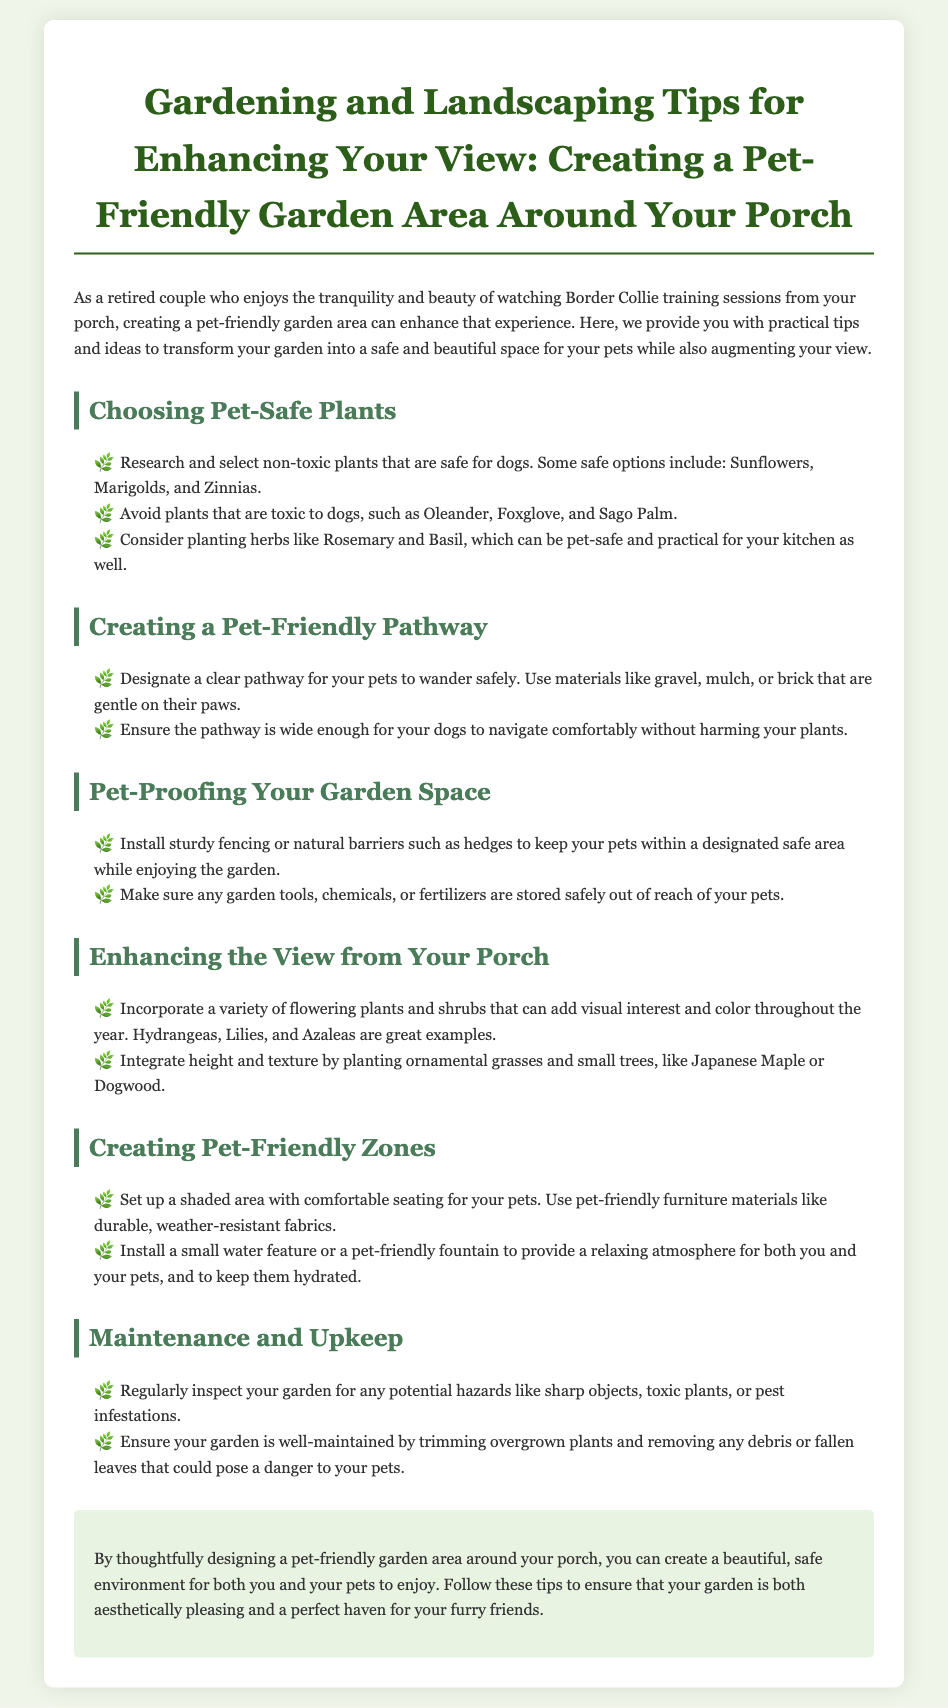What are some pet-safe plants? The document lists specific plants that are non-toxic and safe for dogs, such as Sunflowers, Marigolds, and Zinnias.
Answer: Sunflowers, Marigolds, Zinnias What should be avoided in pet-safe gardening? The document states that plants that are toxic to dogs should be avoided, listing specific examples like Oleander, Foxglove, and Sago Palm.
Answer: Oleander, Foxglove, Sago Palm What materials are recommended for pet-friendly pathways? The document suggests using certain materials for pathways that are gentle on pets' paws, such as gravel, mulch, or brick.
Answer: Gravel, mulch, brick What is a suggested way to enhance the view? The document recommends incorporating a variety of flowering plants and shrubs like Hydrangeas, Lilies, and Azaleas to add visual interest.
Answer: Hydrangeas, Lilies, Azaleas How should garden chemicals be stored? The document advises that garden tools, chemicals, or fertilizers should be stored safely out of reach of pets.
Answer: Safely out of reach What is a beneficial feature to install in a pet-friendly zone? A small water feature or pet-friendly fountain is suggested for creating a relaxing atmosphere for pets.
Answer: Water feature or fountain How often should garden inspections occur? The document recommends regularly inspecting the garden for potential hazards like sharp objects or toxic plants.
Answer: Regularly What type of furniture material is recommended for pet-friendly seating? The document mentions using durable, weather-resistant fabrics for comfortable seating for pets.
Answer: Durable, weather-resistant fabrics 